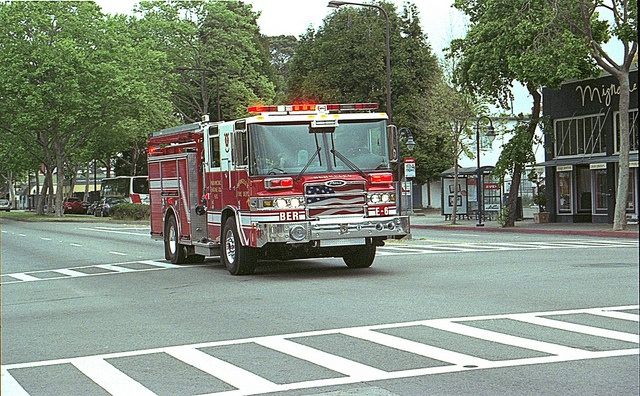Describe the objects in this image and their specific colors. I can see truck in ivory, black, gray, darkgray, and white tones, bus in ivory, black, gray, and darkgray tones, car in ivory, black, gray, darkgreen, and darkgray tones, car in ivory, black, maroon, gray, and brown tones, and bench in ivory, gray, lightblue, black, and darkgray tones in this image. 